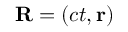Convert formula to latex. <formula><loc_0><loc_0><loc_500><loc_500>R = \left ( c t , r \right )</formula> 